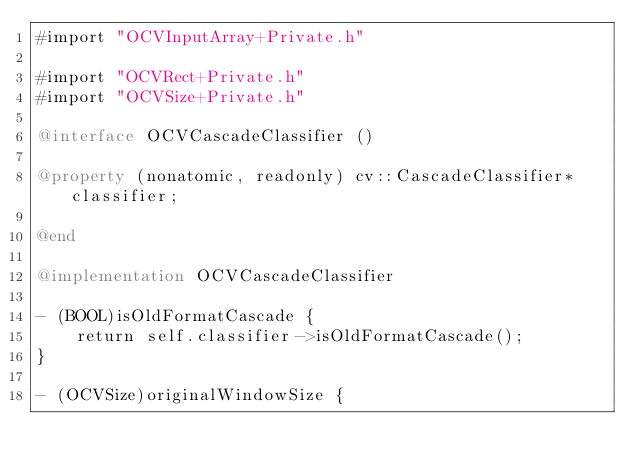<code> <loc_0><loc_0><loc_500><loc_500><_ObjectiveC_>#import "OCVInputArray+Private.h"

#import "OCVRect+Private.h"
#import "OCVSize+Private.h"

@interface OCVCascadeClassifier ()

@property (nonatomic, readonly) cv::CascadeClassifier* classifier;

@end

@implementation OCVCascadeClassifier

- (BOOL)isOldFormatCascade {
    return self.classifier->isOldFormatCascade();
}

- (OCVSize)originalWindowSize {</code> 